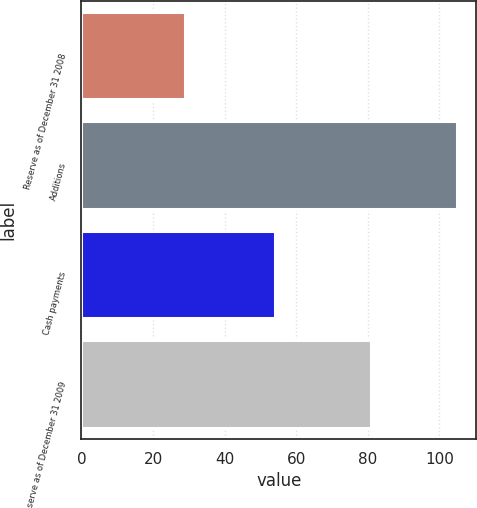Convert chart to OTSL. <chart><loc_0><loc_0><loc_500><loc_500><bar_chart><fcel>Reserve as of December 31 2008<fcel>Additions<fcel>Cash payments<fcel>Reserve as of December 31 2009<nl><fcel>29<fcel>105<fcel>54<fcel>81<nl></chart> 